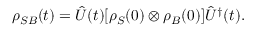Convert formula to latex. <formula><loc_0><loc_0><loc_500><loc_500>\rho _ { S B } ( t ) = { \hat { U } } ( t ) [ \rho _ { S } ( 0 ) \otimes \rho _ { B } ( 0 ) ] { \hat { U } } ^ { \dagger } ( t ) .</formula> 